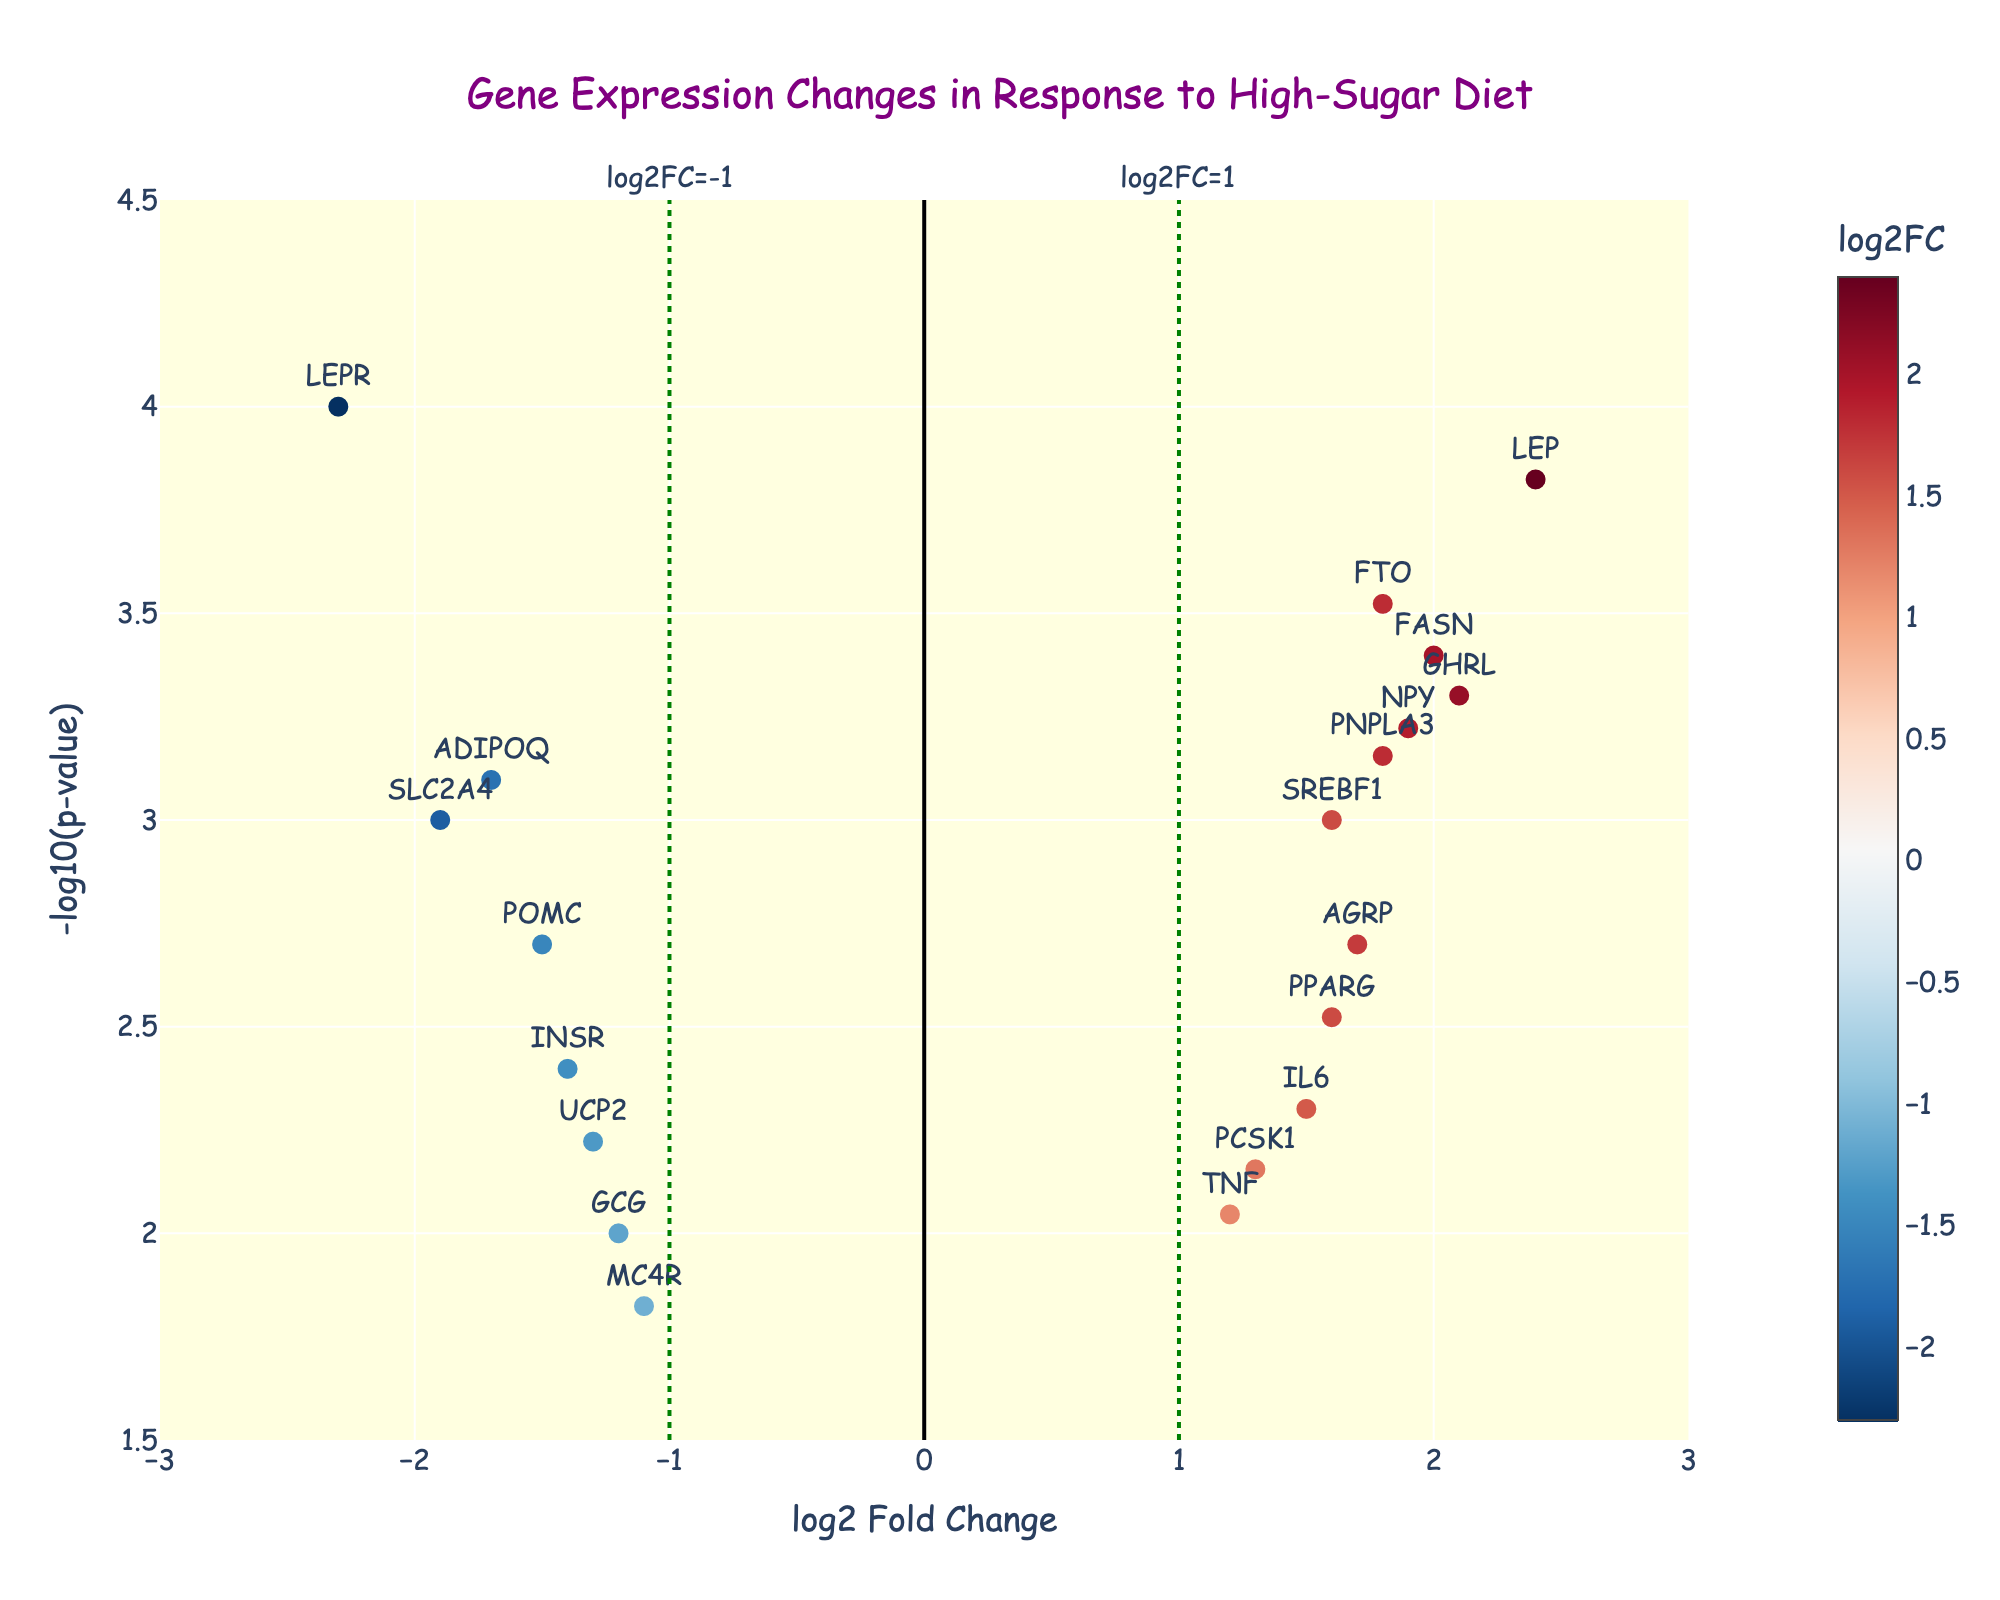How many genes are displayed in the figure? Count the number of distinct markers in the scatter plot representing individual genes. Since each marker corresponds to a gene, we can directly count them. They are: LEPR, FTO, POMC, GHRL, SLC2A4, PPARG, ADIPOQ, LEP, NPY, INSR, GCG, AGRP, MC4R, PCSK1, IL6, TNF, PNPLA3, UCP2, SREBF1, and FASN. This gives us a total of 20 unique genes.
Answer: 20 What is the minimum p-value indicated by any gene in response to the high-sugar diet? Convert the y-axis value back to the original p-value; the minimum y-axis value indicates the maximum -log10(p-value). Checking the maximum -log10(pvalue), which is approximately 4 for LEPR, we take 10^-4.
Answer: 0.0001 Which gene has the highest log2FoldChange value? Identify the gene with the highest x-axis value among positive log2FoldChange values. The highest log2FoldChange is for gene LEP, with a value of 2.4.
Answer: LEP How does the expression level of genes related to appetite, such as NPY and GHRL, change in response to the high-sugar diet? Compare the x-axis values (log2FoldChange) for the genes NPY and GHRL. Both genes have positive log2FoldChange values, with GHRL at 2.1 and NPY at 1.9, indicating an increase in gene expression.
Answer: Increased Which genes show significant changes in gene expression with a log2FoldChange less than -1? Add up genes with log2FoldChange less than -1 and their -log10(p-value) greater than the threshold 1.3. Genes are LEPR (-2.3), POMC (-1.5), SLC2A4 (-1.9), ADIPOQ (-1.7).
Answer: LEPR, POMC, SLC2A4, ADIPOQ Is the gene FTO upregulated or downregulated in response to the high-sugar diet? Look at the log2FoldChange for the gene FTO. Since the log2FoldChange is 1.8, it indicates an upregulation.
Answer: Upregulated Compare the p-values of genes PPARG and IL6. Which one has a more significant p-value? Convert -log10(p-values) for PPARG (3.477) and IL6 (2.301). Higher -log10(p-value) indicates a more significant result. PPARG's value in more significant.
Answer: PPARG Count genes with a log2FoldChange beyond ±1 and a statistically significant p-value (p < 0.05). Consider genes with log2FoldChange beyond -1 or +1. Genes are LEPR, FTO, POMC, GHRL, SLC2A4, PPARG, ADIPOQ, LEP, NPY, AGRP, IL6, PNPLA3, SREBF1, FASN.
Answer: 14 What is the log2FoldChange range of UCP2 in the plot? The log2FoldChange for gene UCP2 is -1.3, consult the x-axis.
Answer: -1.3 